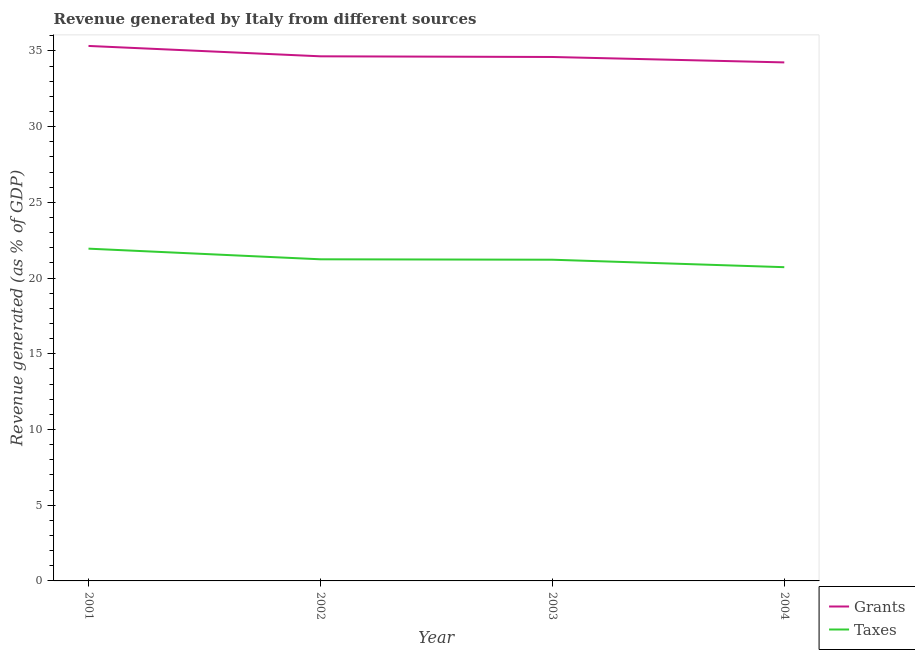How many different coloured lines are there?
Your answer should be very brief. 2. Does the line corresponding to revenue generated by taxes intersect with the line corresponding to revenue generated by grants?
Ensure brevity in your answer.  No. What is the revenue generated by taxes in 2001?
Provide a succinct answer. 21.94. Across all years, what is the maximum revenue generated by taxes?
Offer a terse response. 21.94. Across all years, what is the minimum revenue generated by grants?
Your answer should be very brief. 34.24. In which year was the revenue generated by grants maximum?
Offer a very short reply. 2001. What is the total revenue generated by grants in the graph?
Ensure brevity in your answer.  138.81. What is the difference between the revenue generated by grants in 2001 and that in 2003?
Offer a very short reply. 0.73. What is the difference between the revenue generated by taxes in 2003 and the revenue generated by grants in 2002?
Your answer should be compact. -13.43. What is the average revenue generated by taxes per year?
Provide a short and direct response. 21.28. In the year 2001, what is the difference between the revenue generated by grants and revenue generated by taxes?
Your response must be concise. 13.39. What is the ratio of the revenue generated by taxes in 2001 to that in 2004?
Make the answer very short. 1.06. Is the revenue generated by taxes in 2001 less than that in 2003?
Provide a short and direct response. No. Is the difference between the revenue generated by grants in 2002 and 2003 greater than the difference between the revenue generated by taxes in 2002 and 2003?
Give a very brief answer. Yes. What is the difference between the highest and the second highest revenue generated by grants?
Offer a very short reply. 0.68. What is the difference between the highest and the lowest revenue generated by taxes?
Your answer should be very brief. 1.22. In how many years, is the revenue generated by grants greater than the average revenue generated by grants taken over all years?
Your response must be concise. 1. Is the revenue generated by grants strictly less than the revenue generated by taxes over the years?
Provide a short and direct response. No. How many years are there in the graph?
Your response must be concise. 4. What is the difference between two consecutive major ticks on the Y-axis?
Keep it short and to the point. 5. Does the graph contain any zero values?
Ensure brevity in your answer.  No. How many legend labels are there?
Give a very brief answer. 2. What is the title of the graph?
Provide a succinct answer. Revenue generated by Italy from different sources. Does "Travel Items" appear as one of the legend labels in the graph?
Make the answer very short. No. What is the label or title of the X-axis?
Give a very brief answer. Year. What is the label or title of the Y-axis?
Make the answer very short. Revenue generated (as % of GDP). What is the Revenue generated (as % of GDP) of Grants in 2001?
Offer a terse response. 35.33. What is the Revenue generated (as % of GDP) of Taxes in 2001?
Keep it short and to the point. 21.94. What is the Revenue generated (as % of GDP) of Grants in 2002?
Provide a succinct answer. 34.64. What is the Revenue generated (as % of GDP) of Taxes in 2002?
Ensure brevity in your answer.  21.24. What is the Revenue generated (as % of GDP) in Grants in 2003?
Offer a very short reply. 34.6. What is the Revenue generated (as % of GDP) of Taxes in 2003?
Keep it short and to the point. 21.21. What is the Revenue generated (as % of GDP) of Grants in 2004?
Your answer should be compact. 34.24. What is the Revenue generated (as % of GDP) in Taxes in 2004?
Keep it short and to the point. 20.72. Across all years, what is the maximum Revenue generated (as % of GDP) of Grants?
Provide a short and direct response. 35.33. Across all years, what is the maximum Revenue generated (as % of GDP) of Taxes?
Ensure brevity in your answer.  21.94. Across all years, what is the minimum Revenue generated (as % of GDP) of Grants?
Your response must be concise. 34.24. Across all years, what is the minimum Revenue generated (as % of GDP) of Taxes?
Your response must be concise. 20.72. What is the total Revenue generated (as % of GDP) of Grants in the graph?
Ensure brevity in your answer.  138.81. What is the total Revenue generated (as % of GDP) of Taxes in the graph?
Make the answer very short. 85.11. What is the difference between the Revenue generated (as % of GDP) in Grants in 2001 and that in 2002?
Provide a succinct answer. 0.68. What is the difference between the Revenue generated (as % of GDP) of Taxes in 2001 and that in 2002?
Your answer should be very brief. 0.7. What is the difference between the Revenue generated (as % of GDP) in Grants in 2001 and that in 2003?
Keep it short and to the point. 0.73. What is the difference between the Revenue generated (as % of GDP) of Taxes in 2001 and that in 2003?
Your answer should be compact. 0.73. What is the difference between the Revenue generated (as % of GDP) of Grants in 2001 and that in 2004?
Give a very brief answer. 1.09. What is the difference between the Revenue generated (as % of GDP) in Taxes in 2001 and that in 2004?
Provide a short and direct response. 1.22. What is the difference between the Revenue generated (as % of GDP) of Grants in 2002 and that in 2003?
Offer a terse response. 0.04. What is the difference between the Revenue generated (as % of GDP) in Taxes in 2002 and that in 2003?
Your answer should be compact. 0.03. What is the difference between the Revenue generated (as % of GDP) in Grants in 2002 and that in 2004?
Offer a terse response. 0.4. What is the difference between the Revenue generated (as % of GDP) of Taxes in 2002 and that in 2004?
Your response must be concise. 0.52. What is the difference between the Revenue generated (as % of GDP) in Grants in 2003 and that in 2004?
Make the answer very short. 0.36. What is the difference between the Revenue generated (as % of GDP) in Taxes in 2003 and that in 2004?
Your answer should be compact. 0.49. What is the difference between the Revenue generated (as % of GDP) of Grants in 2001 and the Revenue generated (as % of GDP) of Taxes in 2002?
Your response must be concise. 14.09. What is the difference between the Revenue generated (as % of GDP) in Grants in 2001 and the Revenue generated (as % of GDP) in Taxes in 2003?
Your answer should be very brief. 14.12. What is the difference between the Revenue generated (as % of GDP) of Grants in 2001 and the Revenue generated (as % of GDP) of Taxes in 2004?
Your answer should be very brief. 14.61. What is the difference between the Revenue generated (as % of GDP) in Grants in 2002 and the Revenue generated (as % of GDP) in Taxes in 2003?
Keep it short and to the point. 13.43. What is the difference between the Revenue generated (as % of GDP) of Grants in 2002 and the Revenue generated (as % of GDP) of Taxes in 2004?
Make the answer very short. 13.93. What is the difference between the Revenue generated (as % of GDP) in Grants in 2003 and the Revenue generated (as % of GDP) in Taxes in 2004?
Provide a short and direct response. 13.88. What is the average Revenue generated (as % of GDP) in Grants per year?
Ensure brevity in your answer.  34.7. What is the average Revenue generated (as % of GDP) in Taxes per year?
Keep it short and to the point. 21.28. In the year 2001, what is the difference between the Revenue generated (as % of GDP) of Grants and Revenue generated (as % of GDP) of Taxes?
Provide a short and direct response. 13.39. In the year 2002, what is the difference between the Revenue generated (as % of GDP) in Grants and Revenue generated (as % of GDP) in Taxes?
Ensure brevity in your answer.  13.4. In the year 2003, what is the difference between the Revenue generated (as % of GDP) in Grants and Revenue generated (as % of GDP) in Taxes?
Ensure brevity in your answer.  13.39. In the year 2004, what is the difference between the Revenue generated (as % of GDP) of Grants and Revenue generated (as % of GDP) of Taxes?
Make the answer very short. 13.52. What is the ratio of the Revenue generated (as % of GDP) in Grants in 2001 to that in 2002?
Your response must be concise. 1.02. What is the ratio of the Revenue generated (as % of GDP) in Taxes in 2001 to that in 2002?
Offer a very short reply. 1.03. What is the ratio of the Revenue generated (as % of GDP) of Grants in 2001 to that in 2003?
Your answer should be very brief. 1.02. What is the ratio of the Revenue generated (as % of GDP) in Taxes in 2001 to that in 2003?
Make the answer very short. 1.03. What is the ratio of the Revenue generated (as % of GDP) in Grants in 2001 to that in 2004?
Your answer should be very brief. 1.03. What is the ratio of the Revenue generated (as % of GDP) in Taxes in 2001 to that in 2004?
Your response must be concise. 1.06. What is the ratio of the Revenue generated (as % of GDP) of Grants in 2002 to that in 2004?
Give a very brief answer. 1.01. What is the ratio of the Revenue generated (as % of GDP) of Taxes in 2002 to that in 2004?
Give a very brief answer. 1.03. What is the ratio of the Revenue generated (as % of GDP) in Grants in 2003 to that in 2004?
Ensure brevity in your answer.  1.01. What is the ratio of the Revenue generated (as % of GDP) in Taxes in 2003 to that in 2004?
Your response must be concise. 1.02. What is the difference between the highest and the second highest Revenue generated (as % of GDP) of Grants?
Your answer should be compact. 0.68. What is the difference between the highest and the second highest Revenue generated (as % of GDP) of Taxes?
Offer a very short reply. 0.7. What is the difference between the highest and the lowest Revenue generated (as % of GDP) in Grants?
Make the answer very short. 1.09. What is the difference between the highest and the lowest Revenue generated (as % of GDP) of Taxes?
Ensure brevity in your answer.  1.22. 